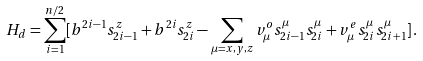<formula> <loc_0><loc_0><loc_500><loc_500>H _ { d } = \sum _ { i = 1 } ^ { n / 2 } [ b ^ { 2 i - 1 } s ^ { z } _ { 2 i - 1 } + b ^ { 2 i } s ^ { z } _ { 2 i } - \sum _ { \mu = x , y , z } v ^ { o } _ { \mu } s ^ { \mu } _ { 2 i - 1 } s ^ { \mu } _ { 2 i } + v ^ { e } _ { \mu } s ^ { \mu } _ { 2 i } s ^ { \mu } _ { 2 i + 1 } ] \, .</formula> 